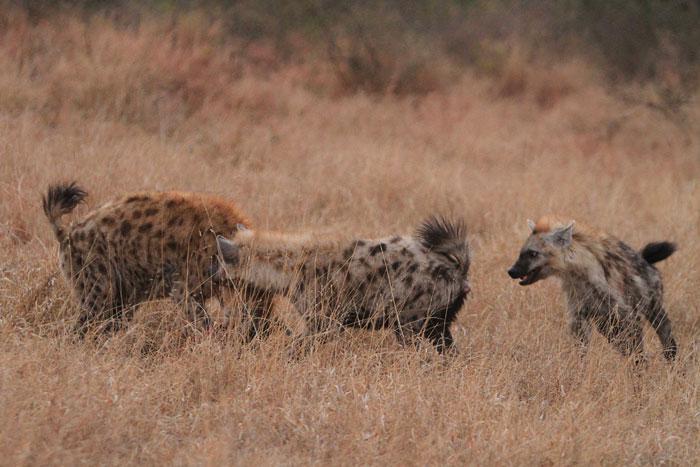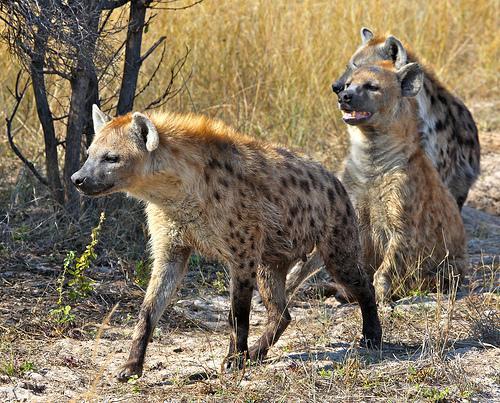The first image is the image on the left, the second image is the image on the right. Evaluate the accuracy of this statement regarding the images: "One image contains a single hyena.". Is it true? Answer yes or no. No. 